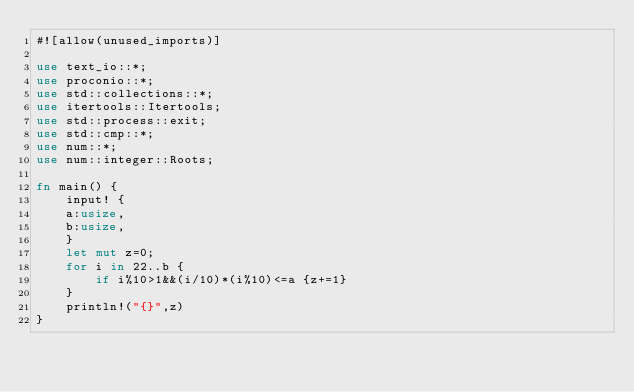Convert code to text. <code><loc_0><loc_0><loc_500><loc_500><_Rust_>#![allow(unused_imports)]

use text_io::*;
use proconio::*;
use std::collections::*;
use itertools::Itertools;
use std::process::exit;
use std::cmp::*;
use num::*;
use num::integer::Roots;

fn main() {
    input! {
    a:usize,
    b:usize,
    }
    let mut z=0;
    for i in 22..b {
        if i%10>1&&(i/10)*(i%10)<=a {z+=1}
    }
    println!("{}",z)
}</code> 